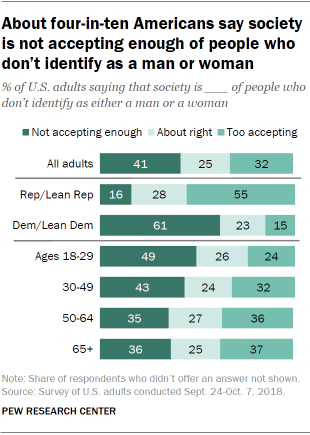Highlight a few significant elements in this photo. Yes, only three colors are used to represent the graph. The difference in averages between the ages of all individuals in the 18-29 age group and the largest age group included in the "All adults" category is 8. 